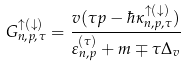<formula> <loc_0><loc_0><loc_500><loc_500>G ^ { \uparrow ( \downarrow ) } _ { n , p , \tau } = \frac { v ( \tau p - \hbar { \kappa } ^ { \uparrow ( \downarrow ) } _ { n , p , \tau } ) } { \varepsilon _ { n , p } ^ { ( \tau ) } + m \mp \tau \Delta _ { v } }</formula> 